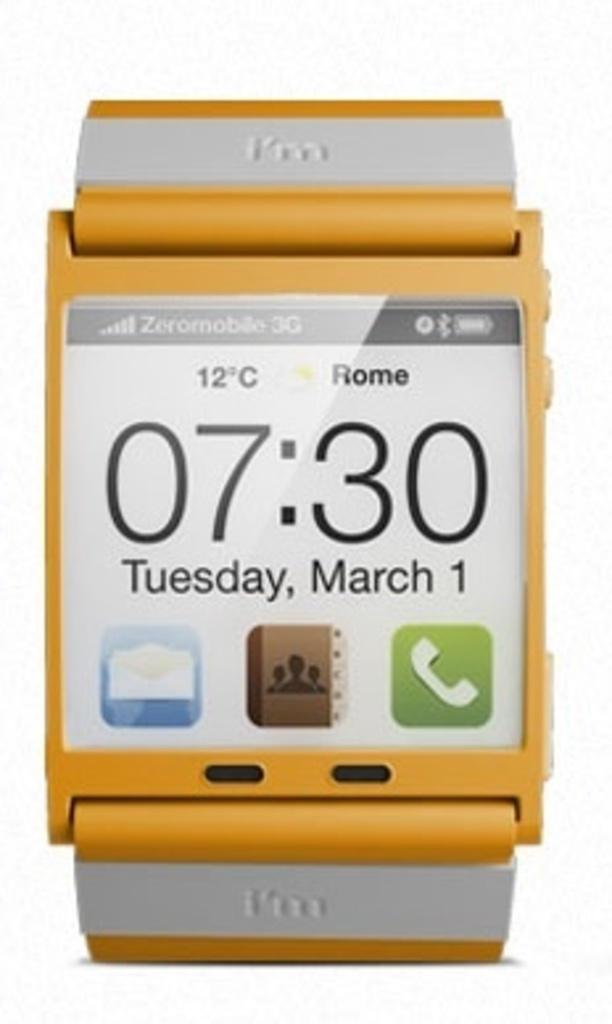<image>
Render a clear and concise summary of the photo. A yellow smart watch that says 07:30 Tuesday, March 1. 